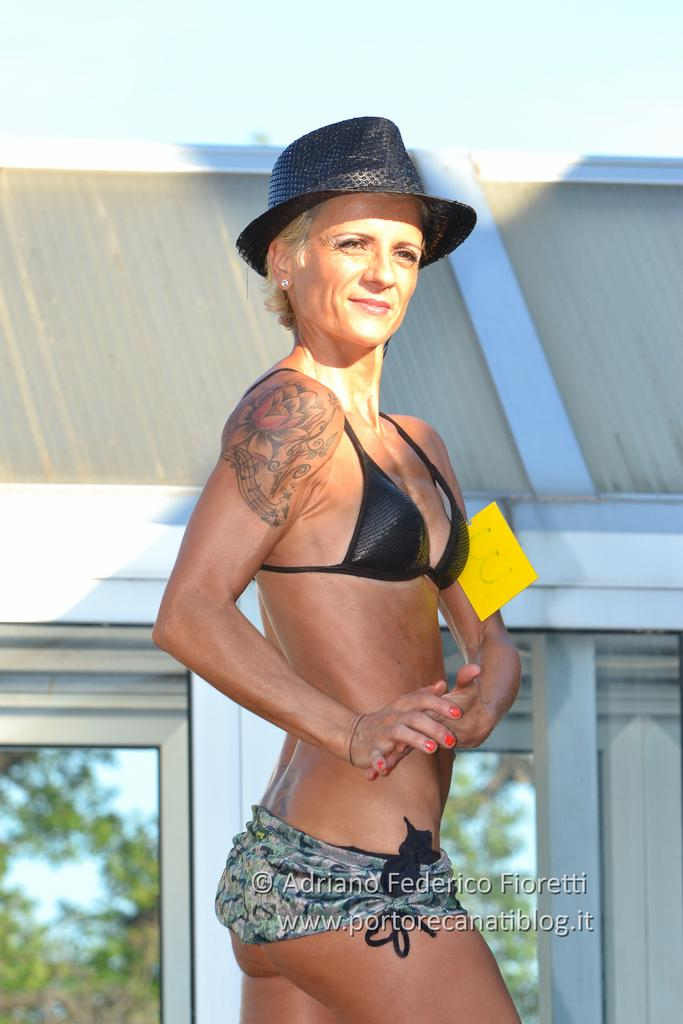Who is present in the image? There is a woman in the image. What is the woman doing in the image? The woman is standing. What is the woman wearing on her head? The woman is wearing a black hat. What color is the object in the image? There is a yellow object in the image. What can be seen in the background of the image? There is a building in the background of the image. What time of day does the woman feel shame in the image? There is no indication in the image that the woman feels shame, and the time of day is not mentioned. 